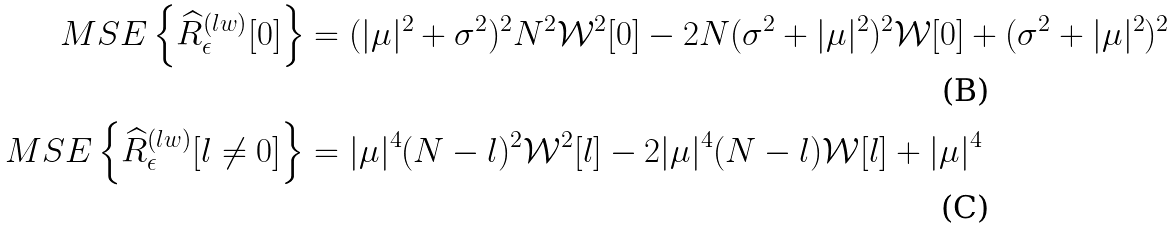Convert formula to latex. <formula><loc_0><loc_0><loc_500><loc_500>M S E \left \{ \widehat { R } _ { \epsilon } ^ { ( l w ) } [ 0 ] \right \} & = ( | \mu | ^ { 2 } + \sigma ^ { 2 } ) ^ { 2 } N ^ { 2 } \mathcal { W } ^ { 2 } [ 0 ] - 2 N ( \sigma ^ { 2 } + | \mu | ^ { 2 } ) ^ { 2 } \mathcal { W } [ 0 ] + ( \sigma ^ { 2 } + | \mu | ^ { 2 } ) ^ { 2 } \\ M S E \left \{ \widehat { R } _ { \epsilon } ^ { ( l w ) } [ l \neq 0 ] \right \} & = | \mu | ^ { 4 } ( N - l ) ^ { 2 } \mathcal { W } ^ { 2 } [ l ] - 2 | \mu | ^ { 4 } ( N - l ) \mathcal { W } [ l ] + | \mu | ^ { 4 }</formula> 